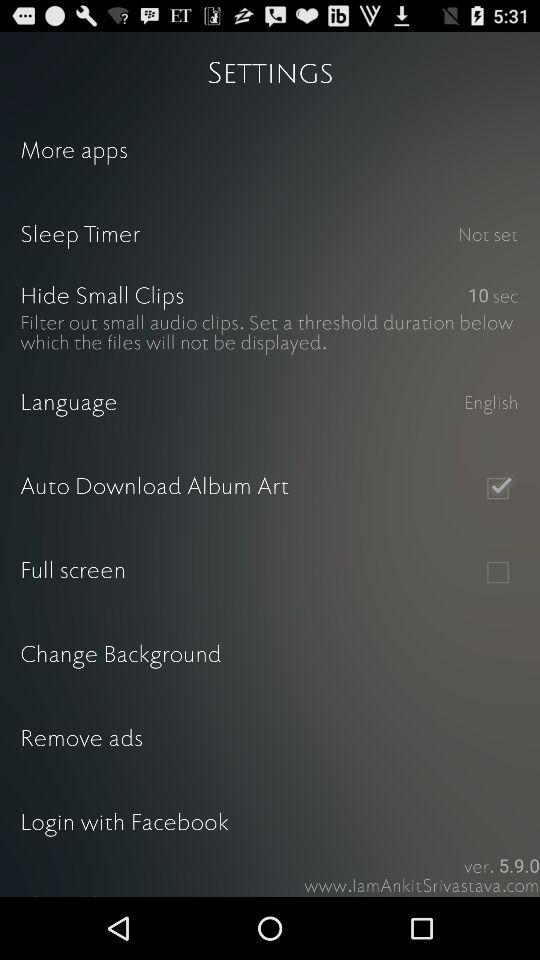What is the version? The version is 5.9.0. 